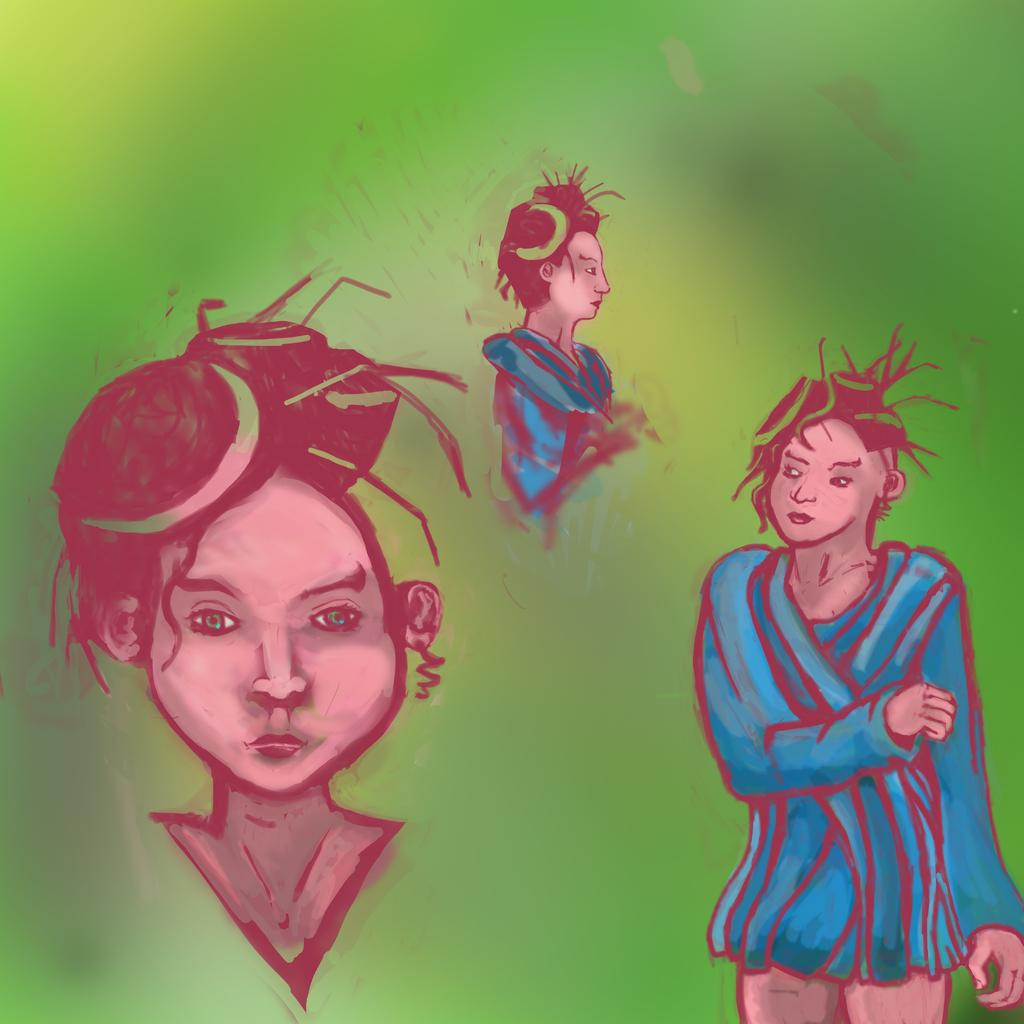What is the main subject of the image? There is a painting in the image. What is being depicted in the painting? The painting depicts people. What color is the background of the painting? The background of the painting is green. How many nuts are hanging from the branch in the painting? There are no nuts or branches present in the painting; it depicts people with a green background. 